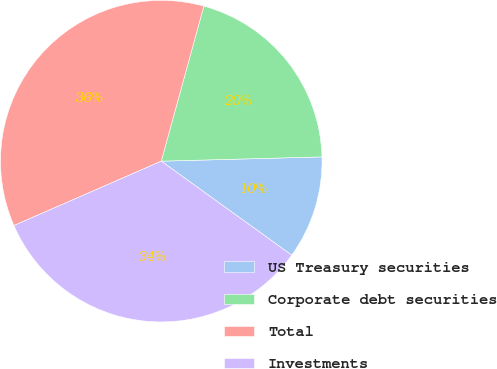<chart> <loc_0><loc_0><loc_500><loc_500><pie_chart><fcel>US Treasury securities<fcel>Corporate debt securities<fcel>Total<fcel>Investments<nl><fcel>10.36%<fcel>20.31%<fcel>35.82%<fcel>33.5%<nl></chart> 